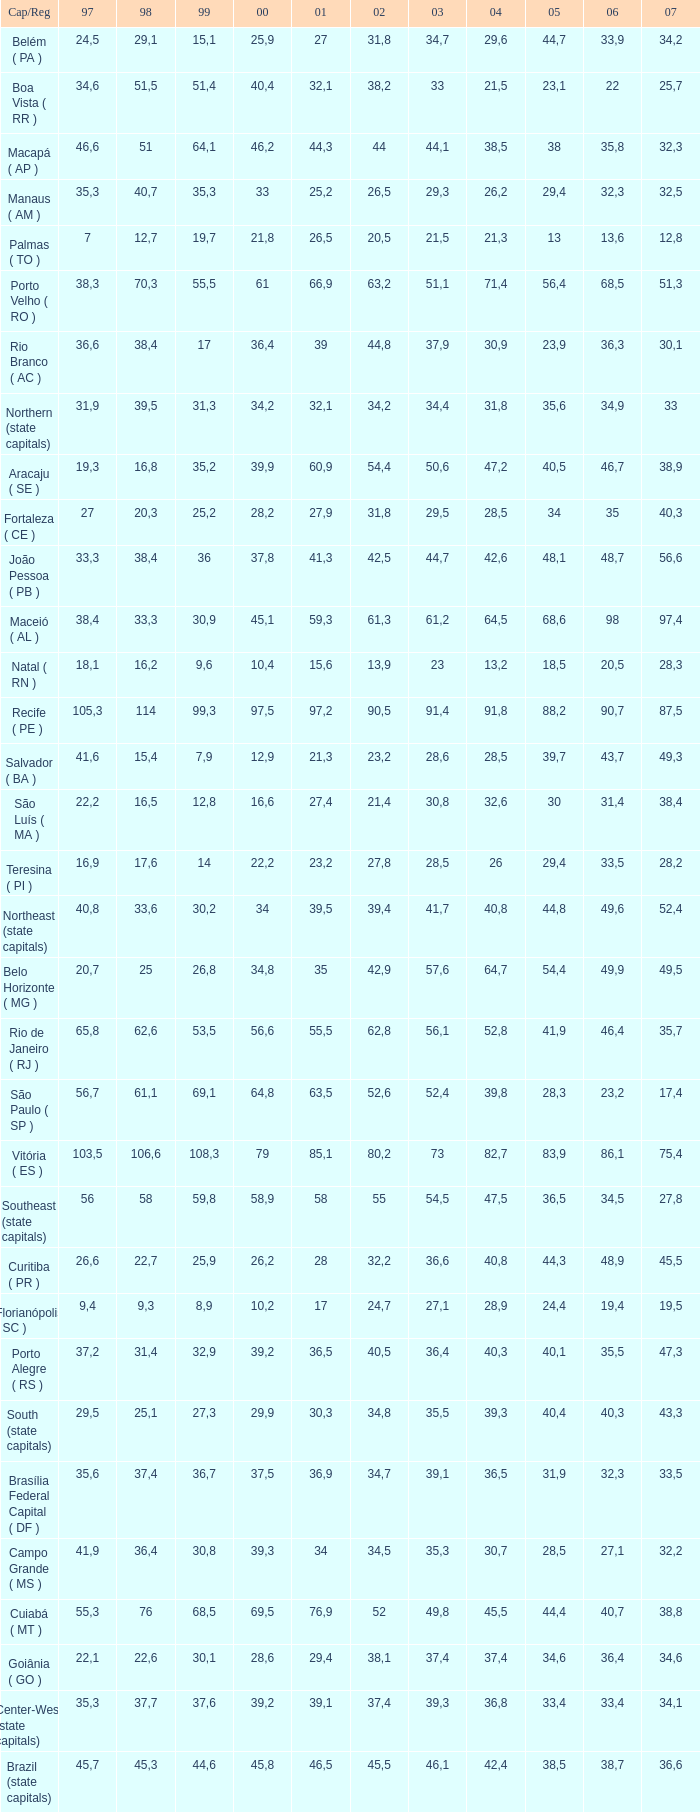How many 2007's have a 2003 less than 36,4, 27,9 as a 2001, and a 1999 less than 25,2? None. 